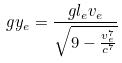<formula> <loc_0><loc_0><loc_500><loc_500>g y _ { e } = \frac { g l _ { e } v _ { e } } { \sqrt { 9 - \frac { v _ { e } ^ { 7 } } { c ^ { 7 } } } }</formula> 